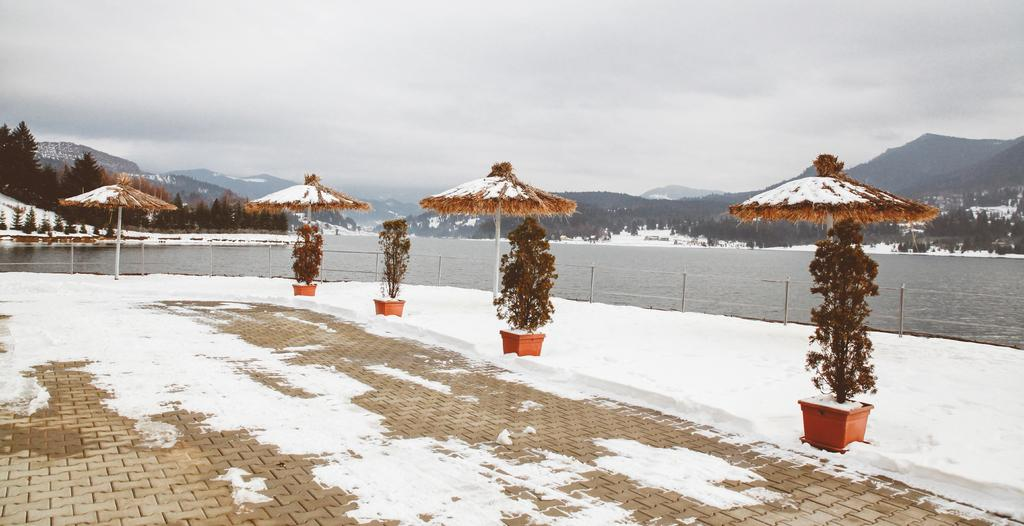What is the condition of the ground in the image? The ground is covered with snow. Where are the plant pots located in the image? The plant pots are in the right corner of the image. What type of barrier can be seen in the image? There is a fence in the image. What can be seen in the background of the image? Water, trees, and mountains are visible in the background. What type of cap is the laborer wearing in the image? There is no laborer or cap present in the image. 